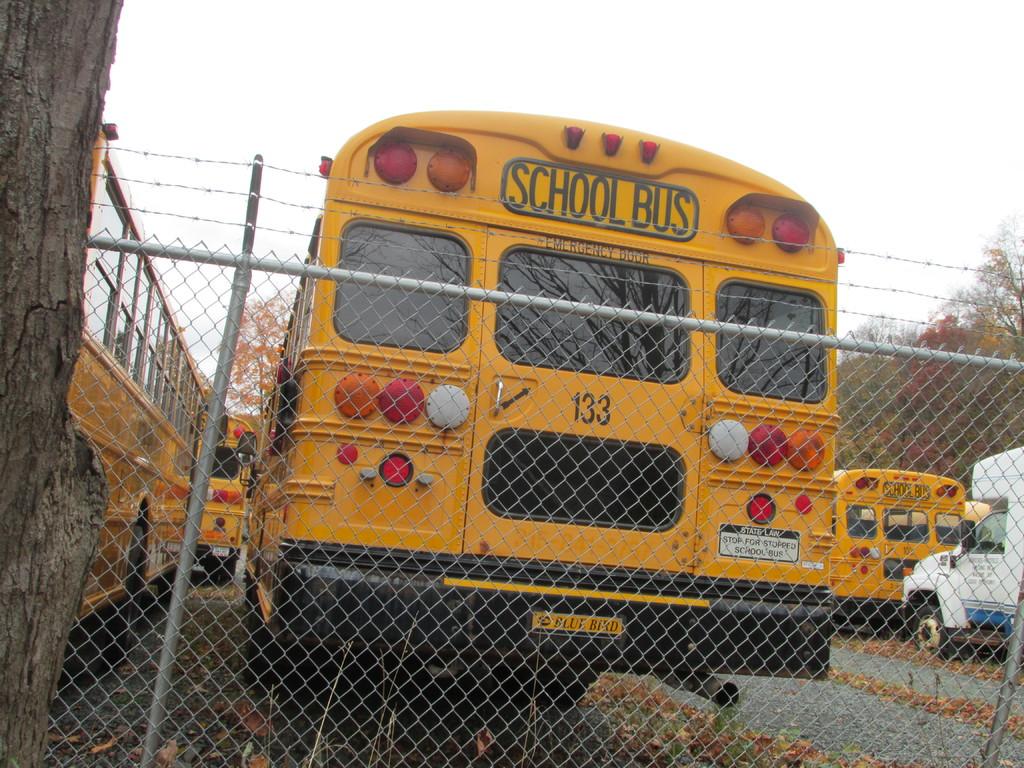What kind of bus is this?
Give a very brief answer. School bus. What is the bus number?
Provide a short and direct response. 133. 